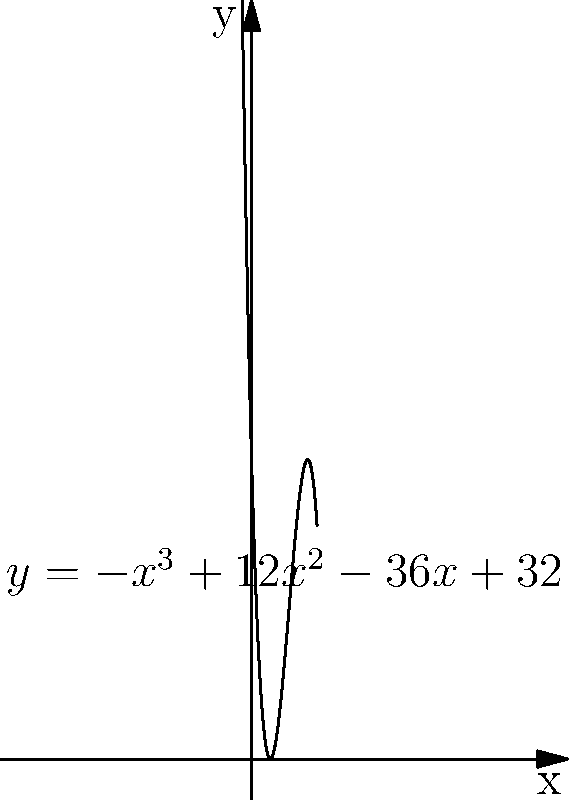You're designing an optimal training schedule for your next MMA fight. Your performance function is modeled by the equation $y = -x^3 + 12x^2 - 36x + 32$, where $x$ represents the number of hours trained per day and $y$ represents your performance level. To maximize your performance, you need to find the roots of the derivative of this function. What is the optimal number of hours you should train per day to achieve peak performance? 1) First, we need to find the derivative of the performance function:
   $\frac{dy}{dx} = -3x^2 + 24x - 36$

2) To find the maximum, we set the derivative equal to zero:
   $-3x^2 + 24x - 36 = 0$

3) This is a quadratic equation. We can solve it using the quadratic formula:
   $x = \frac{-b \pm \sqrt{b^2 - 4ac}}{2a}$

   Where $a = -3$, $b = 24$, and $c = -36$

4) Substituting these values:
   $x = \frac{-24 \pm \sqrt{24^2 - 4(-3)(-36)}}{2(-3)}$

5) Simplifying:
   $x = \frac{-24 \pm \sqrt{576 - 432}}{-6} = \frac{-24 \pm \sqrt{144}}{-6} = \frac{-24 \pm 12}{-6}$

6) This gives us two solutions:
   $x_1 = \frac{-24 + 12}{-6} = 2$ and $x_2 = \frac{-24 - 12}{-6} = 6$

7) To determine which solution gives the maximum, we can check the second derivative:
   $\frac{d^2y}{dx^2} = -6x + 24$

8) At $x = 2$: $-6(2) + 24 = 12$ (positive, local minimum)
   At $x = 6$: $-6(6) + 24 = -12$ (negative, local maximum)

Therefore, the optimal number of training hours per day is 6.
Answer: 6 hours 